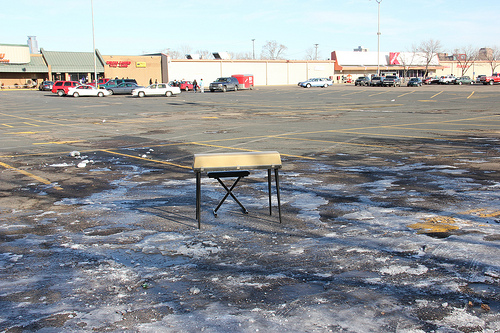<image>
Is there a car behind the wall? No. The car is not behind the wall. From this viewpoint, the car appears to be positioned elsewhere in the scene. Is there a cars above the table? No. The cars is not positioned above the table. The vertical arrangement shows a different relationship. 